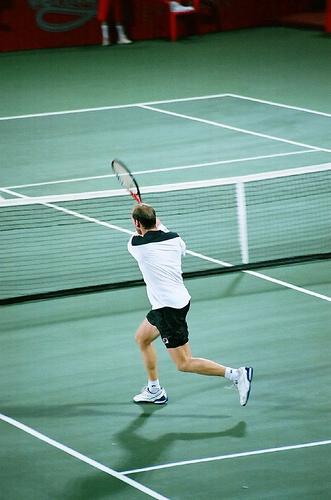What sport is this person playing?
Keep it brief. Tennis. What is he doing right now?
Give a very brief answer. Playing tennis. Is this person moving?
Write a very short answer. Yes. 